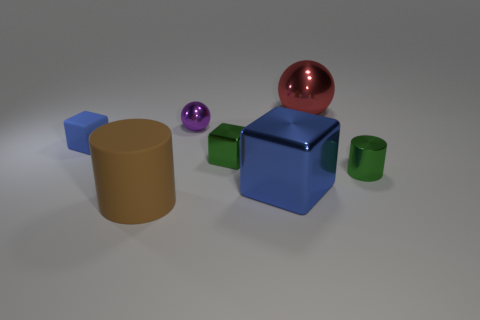Subtract all small blocks. How many blocks are left? 1 Add 2 green metal cylinders. How many objects exist? 9 Subtract all cyan spheres. How many blue cubes are left? 2 Subtract all green blocks. How many blocks are left? 2 Subtract all cylinders. How many objects are left? 5 Add 2 purple matte things. How many purple matte things exist? 2 Subtract 0 yellow spheres. How many objects are left? 7 Subtract all brown cubes. Subtract all red balls. How many cubes are left? 3 Subtract all big metal cubes. Subtract all tiny brown objects. How many objects are left? 6 Add 4 green blocks. How many green blocks are left? 5 